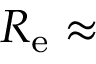<formula> <loc_0><loc_0><loc_500><loc_500>R _ { e } \approx</formula> 